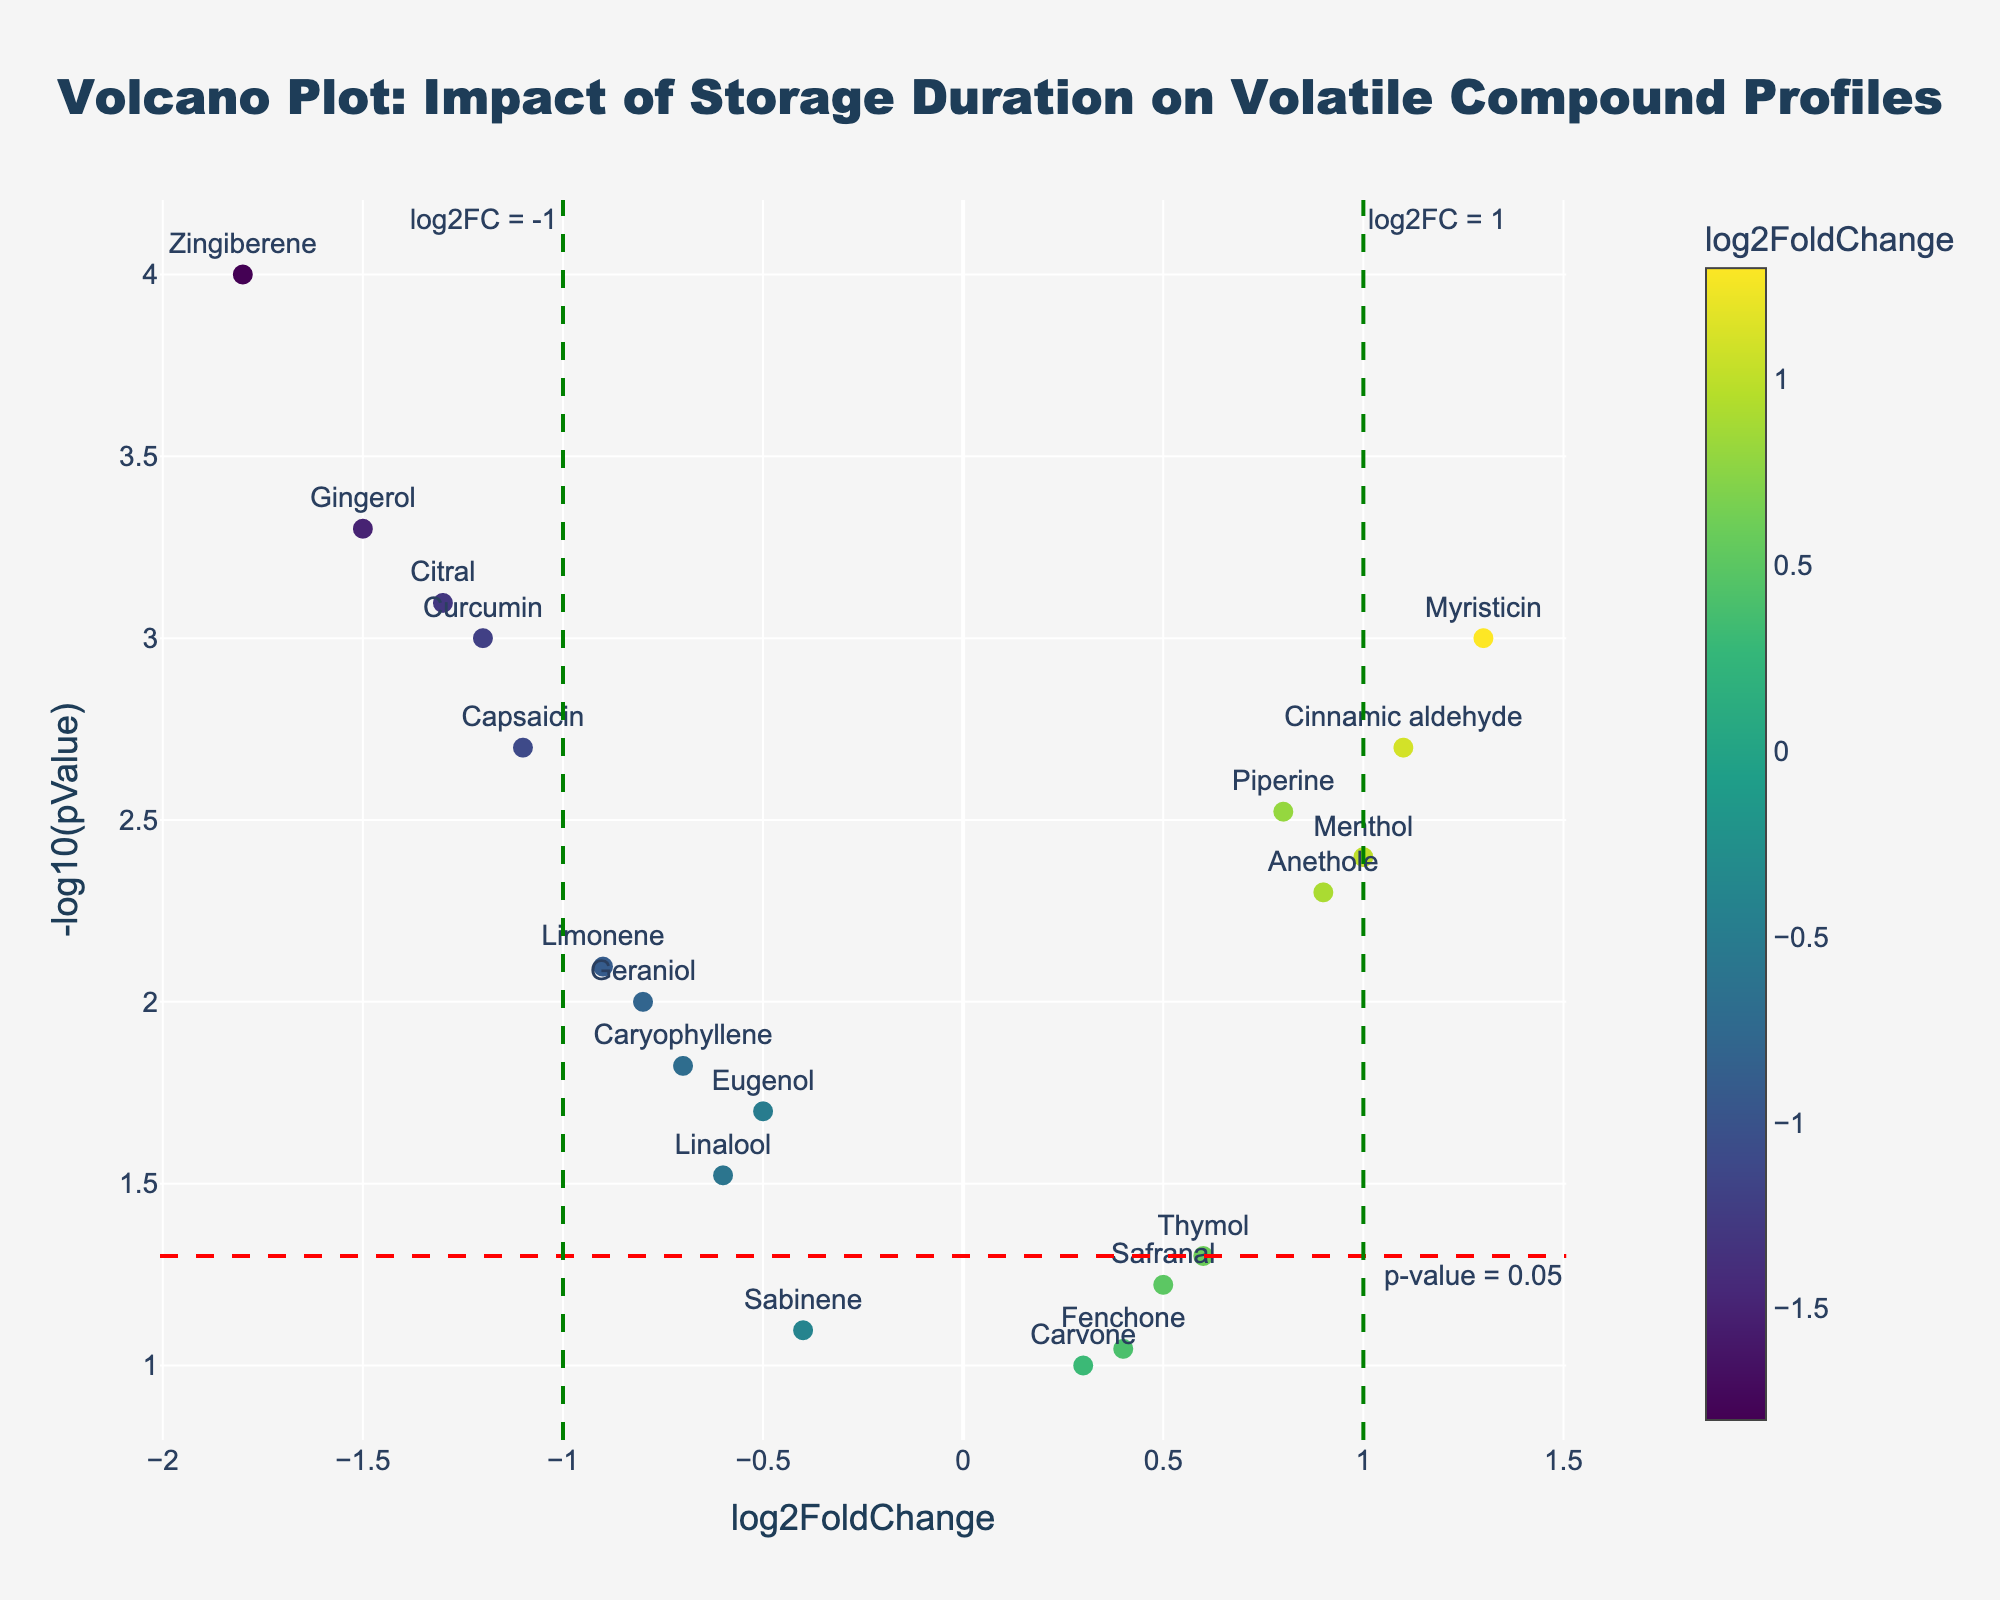What is the title of this plot? The title is clearly displayed at the top of the plot. It reads "Volcano Plot: Impact of Storage Duration on Volatile Compound Profiles".
Answer: Volcano Plot: Impact of Storage Duration on Volatile Compound Profiles How many compounds have a p-value less than 0.05? To find this, you can refer to the y-axis, which shows -log10(pValue). A p-value of 0.05 corresponds to a -log10(pValue) of 1.3. Count the number of points above this threshold.
Answer: 13 Which compound shows the highest negative log2FoldChange? The x-axis represents log2FoldChange. The compound with the highest negative value will be the farthest left on the x-axis.
Answer: Zingiberene What does a vertical line on log2FC = 1 represent? The plot has a vertical dashed line at log2FC = 1. The annotation indicates it is a threshold for significant positive log2FoldChange.
Answer: Threshold for significant positive change Which compound has the smallest p-value? The smallest p-value will have the highest -log10(pValue) value. Look for the highest point on the y-axis.
Answer: Zingiberene How many compounds have a log2FoldChange greater than 1? Look to the right of the green dashed vertical line at log2FoldChange = 1. Count the number of data points in this region.
Answer: 2 What colors are used to indicate higher and lower log2FoldChange values? The plot uses a color scale (Viridis) to indicate fold changes. Higher log2FC values are in yellow while lower log2FC values are in dark blue.
Answer: Yellow and dark blue Which compound shows a significant increase in concentration with a p-value less than 0.05 and log2FoldChange greater than 1? Following the vertical line at log2FC = 1 and the horizontal line at -log10(pValue) = 1.3 (red line for p-value 0.05), identify the point that meets both criteria.
Answer: Myristicin Identify the compounds with a p-value less than 0.05 and log2FoldChange less than -1. Below the -log10(pValue) threshold of 1.3 and left of -log2FoldChange of -1, identify the data points.
Answer: Curcumin, Gingerol, Zingiberene, Citral, Capsaicin 